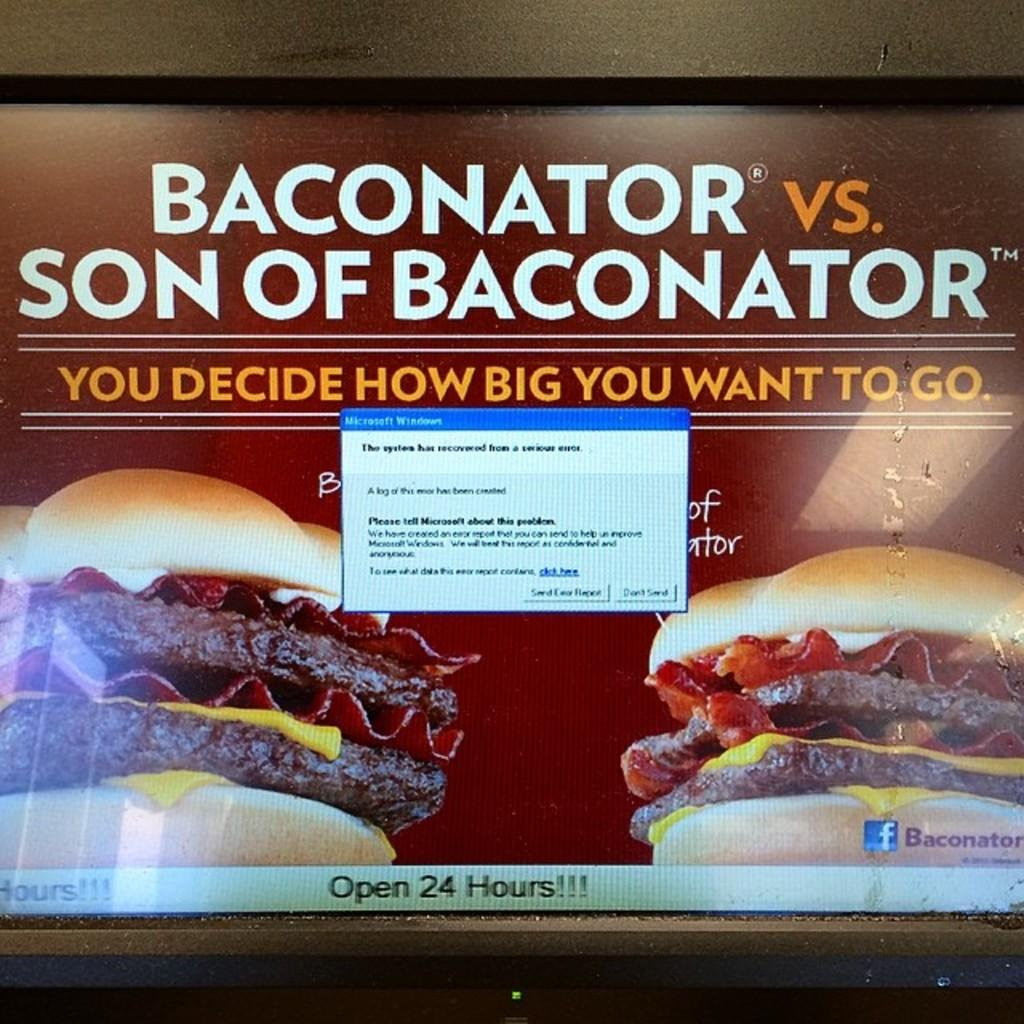What is located on the wall in the foreground of the image? There is a screen on the wall in the foreground of the image. What can be seen on the screen? There is some text visible on the screen, as well as a dialogue box. What type of images are present on either side of the screen? There are images of a burger on either side of the screen. How does the burger stretch across the screen in the image? The burger does not stretch across the screen in the image; it is depicted as two separate images on either side of the screen. 